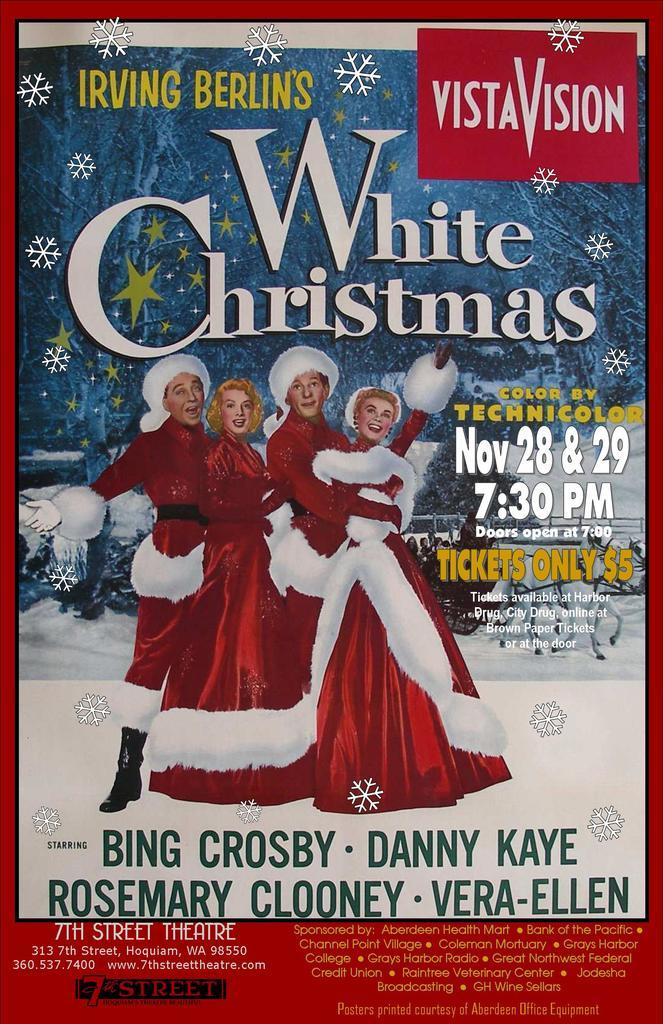What is present in the image? There is a poster in the image. What is depicted on the poster? The poster features four people. What are the people wearing in the poster? The people are dressed in Christmas costumes. What type of competition is taking place in the image? There is no competition present in the image; it features a poster with four people dressed in Christmas costumes. How many rabbits can be seen in the image? There are no rabbits present in the image. 